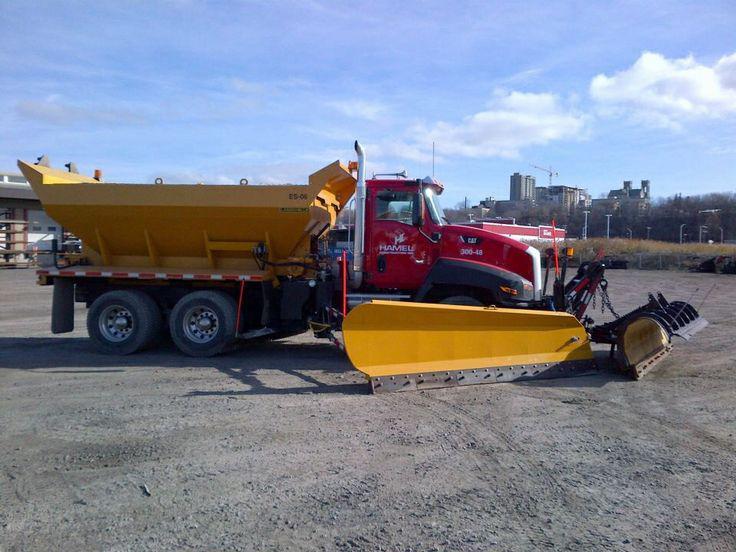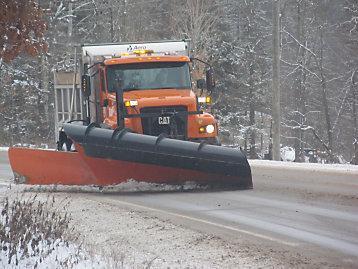The first image is the image on the left, the second image is the image on the right. Examine the images to the left and right. Is the description "one of the trucks is red" accurate? Answer yes or no. Yes. 